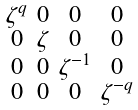Convert formula to latex. <formula><loc_0><loc_0><loc_500><loc_500>\begin{smallmatrix} \zeta ^ { q } & 0 & 0 & 0 \\ 0 & \zeta & 0 & 0 \\ 0 & 0 & \zeta ^ { - 1 } & 0 \\ 0 & 0 & 0 & \zeta ^ { - q } \end{smallmatrix}</formula> 